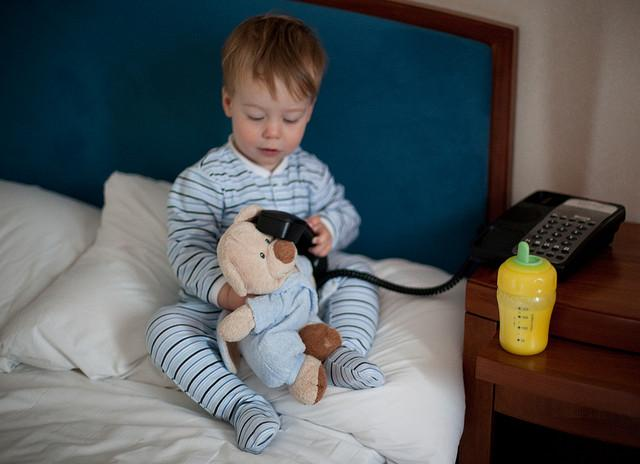What does the child imagine his toy bear does now? phone call 